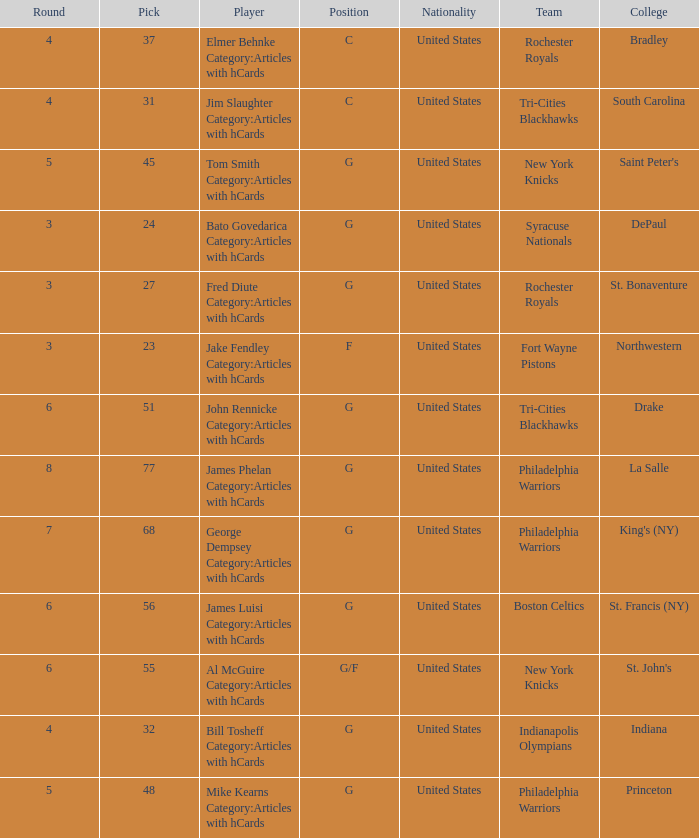What is the sum total of picks for drake players from the tri-cities blackhawks? 51.0. 